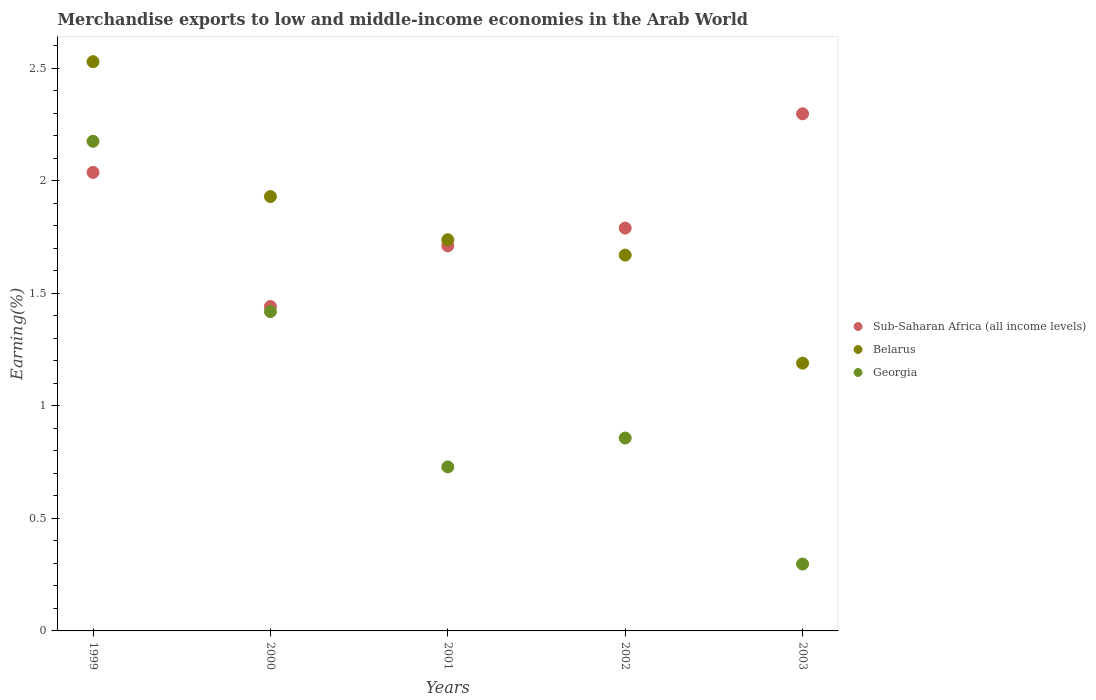How many different coloured dotlines are there?
Your response must be concise. 3. Is the number of dotlines equal to the number of legend labels?
Keep it short and to the point. Yes. What is the percentage of amount earned from merchandise exports in Belarus in 2002?
Offer a very short reply. 1.67. Across all years, what is the maximum percentage of amount earned from merchandise exports in Belarus?
Ensure brevity in your answer.  2.53. Across all years, what is the minimum percentage of amount earned from merchandise exports in Georgia?
Your answer should be very brief. 0.3. What is the total percentage of amount earned from merchandise exports in Sub-Saharan Africa (all income levels) in the graph?
Your answer should be very brief. 9.28. What is the difference between the percentage of amount earned from merchandise exports in Sub-Saharan Africa (all income levels) in 1999 and that in 2001?
Your answer should be compact. 0.33. What is the difference between the percentage of amount earned from merchandise exports in Sub-Saharan Africa (all income levels) in 2002 and the percentage of amount earned from merchandise exports in Georgia in 2001?
Make the answer very short. 1.06. What is the average percentage of amount earned from merchandise exports in Sub-Saharan Africa (all income levels) per year?
Keep it short and to the point. 1.86. In the year 2001, what is the difference between the percentage of amount earned from merchandise exports in Georgia and percentage of amount earned from merchandise exports in Belarus?
Your answer should be compact. -1.01. What is the ratio of the percentage of amount earned from merchandise exports in Sub-Saharan Africa (all income levels) in 2001 to that in 2003?
Your answer should be very brief. 0.74. Is the difference between the percentage of amount earned from merchandise exports in Georgia in 2000 and 2002 greater than the difference between the percentage of amount earned from merchandise exports in Belarus in 2000 and 2002?
Offer a very short reply. Yes. What is the difference between the highest and the second highest percentage of amount earned from merchandise exports in Sub-Saharan Africa (all income levels)?
Your answer should be compact. 0.26. What is the difference between the highest and the lowest percentage of amount earned from merchandise exports in Belarus?
Your answer should be compact. 1.34. In how many years, is the percentage of amount earned from merchandise exports in Sub-Saharan Africa (all income levels) greater than the average percentage of amount earned from merchandise exports in Sub-Saharan Africa (all income levels) taken over all years?
Provide a short and direct response. 2. Is the sum of the percentage of amount earned from merchandise exports in Georgia in 1999 and 2001 greater than the maximum percentage of amount earned from merchandise exports in Belarus across all years?
Make the answer very short. Yes. Does the percentage of amount earned from merchandise exports in Sub-Saharan Africa (all income levels) monotonically increase over the years?
Offer a very short reply. No. How many dotlines are there?
Offer a terse response. 3. How many years are there in the graph?
Ensure brevity in your answer.  5. Are the values on the major ticks of Y-axis written in scientific E-notation?
Ensure brevity in your answer.  No. Does the graph contain any zero values?
Offer a very short reply. No. Does the graph contain grids?
Your response must be concise. No. How many legend labels are there?
Your answer should be compact. 3. How are the legend labels stacked?
Provide a short and direct response. Vertical. What is the title of the graph?
Your response must be concise. Merchandise exports to low and middle-income economies in the Arab World. Does "Kosovo" appear as one of the legend labels in the graph?
Ensure brevity in your answer.  No. What is the label or title of the Y-axis?
Keep it short and to the point. Earning(%). What is the Earning(%) in Sub-Saharan Africa (all income levels) in 1999?
Give a very brief answer. 2.04. What is the Earning(%) in Belarus in 1999?
Offer a terse response. 2.53. What is the Earning(%) of Georgia in 1999?
Provide a short and direct response. 2.18. What is the Earning(%) in Sub-Saharan Africa (all income levels) in 2000?
Provide a succinct answer. 1.44. What is the Earning(%) of Belarus in 2000?
Your response must be concise. 1.93. What is the Earning(%) in Georgia in 2000?
Provide a succinct answer. 1.42. What is the Earning(%) of Sub-Saharan Africa (all income levels) in 2001?
Your response must be concise. 1.71. What is the Earning(%) in Belarus in 2001?
Provide a succinct answer. 1.74. What is the Earning(%) of Georgia in 2001?
Offer a terse response. 0.73. What is the Earning(%) of Sub-Saharan Africa (all income levels) in 2002?
Ensure brevity in your answer.  1.79. What is the Earning(%) of Belarus in 2002?
Offer a very short reply. 1.67. What is the Earning(%) of Georgia in 2002?
Offer a very short reply. 0.86. What is the Earning(%) in Sub-Saharan Africa (all income levels) in 2003?
Your answer should be very brief. 2.3. What is the Earning(%) in Belarus in 2003?
Ensure brevity in your answer.  1.19. What is the Earning(%) of Georgia in 2003?
Give a very brief answer. 0.3. Across all years, what is the maximum Earning(%) of Sub-Saharan Africa (all income levels)?
Your answer should be very brief. 2.3. Across all years, what is the maximum Earning(%) of Belarus?
Offer a terse response. 2.53. Across all years, what is the maximum Earning(%) of Georgia?
Your answer should be compact. 2.18. Across all years, what is the minimum Earning(%) of Sub-Saharan Africa (all income levels)?
Offer a very short reply. 1.44. Across all years, what is the minimum Earning(%) in Belarus?
Provide a short and direct response. 1.19. Across all years, what is the minimum Earning(%) of Georgia?
Offer a very short reply. 0.3. What is the total Earning(%) in Sub-Saharan Africa (all income levels) in the graph?
Offer a terse response. 9.28. What is the total Earning(%) of Belarus in the graph?
Make the answer very short. 9.06. What is the total Earning(%) in Georgia in the graph?
Offer a terse response. 5.48. What is the difference between the Earning(%) of Sub-Saharan Africa (all income levels) in 1999 and that in 2000?
Provide a succinct answer. 0.6. What is the difference between the Earning(%) in Belarus in 1999 and that in 2000?
Offer a very short reply. 0.6. What is the difference between the Earning(%) in Georgia in 1999 and that in 2000?
Keep it short and to the point. 0.76. What is the difference between the Earning(%) in Sub-Saharan Africa (all income levels) in 1999 and that in 2001?
Keep it short and to the point. 0.33. What is the difference between the Earning(%) of Belarus in 1999 and that in 2001?
Make the answer very short. 0.79. What is the difference between the Earning(%) of Georgia in 1999 and that in 2001?
Your answer should be compact. 1.45. What is the difference between the Earning(%) of Sub-Saharan Africa (all income levels) in 1999 and that in 2002?
Provide a succinct answer. 0.25. What is the difference between the Earning(%) in Belarus in 1999 and that in 2002?
Make the answer very short. 0.86. What is the difference between the Earning(%) of Georgia in 1999 and that in 2002?
Provide a succinct answer. 1.32. What is the difference between the Earning(%) in Sub-Saharan Africa (all income levels) in 1999 and that in 2003?
Give a very brief answer. -0.26. What is the difference between the Earning(%) in Belarus in 1999 and that in 2003?
Provide a short and direct response. 1.34. What is the difference between the Earning(%) in Georgia in 1999 and that in 2003?
Ensure brevity in your answer.  1.88. What is the difference between the Earning(%) of Sub-Saharan Africa (all income levels) in 2000 and that in 2001?
Provide a short and direct response. -0.27. What is the difference between the Earning(%) in Belarus in 2000 and that in 2001?
Keep it short and to the point. 0.19. What is the difference between the Earning(%) of Georgia in 2000 and that in 2001?
Provide a succinct answer. 0.69. What is the difference between the Earning(%) in Sub-Saharan Africa (all income levels) in 2000 and that in 2002?
Your response must be concise. -0.35. What is the difference between the Earning(%) of Belarus in 2000 and that in 2002?
Keep it short and to the point. 0.26. What is the difference between the Earning(%) in Georgia in 2000 and that in 2002?
Your answer should be very brief. 0.56. What is the difference between the Earning(%) of Sub-Saharan Africa (all income levels) in 2000 and that in 2003?
Keep it short and to the point. -0.86. What is the difference between the Earning(%) of Belarus in 2000 and that in 2003?
Provide a succinct answer. 0.74. What is the difference between the Earning(%) of Georgia in 2000 and that in 2003?
Your answer should be very brief. 1.12. What is the difference between the Earning(%) in Sub-Saharan Africa (all income levels) in 2001 and that in 2002?
Your response must be concise. -0.08. What is the difference between the Earning(%) in Belarus in 2001 and that in 2002?
Provide a succinct answer. 0.07. What is the difference between the Earning(%) of Georgia in 2001 and that in 2002?
Keep it short and to the point. -0.13. What is the difference between the Earning(%) of Sub-Saharan Africa (all income levels) in 2001 and that in 2003?
Your response must be concise. -0.59. What is the difference between the Earning(%) of Belarus in 2001 and that in 2003?
Your response must be concise. 0.55. What is the difference between the Earning(%) of Georgia in 2001 and that in 2003?
Your response must be concise. 0.43. What is the difference between the Earning(%) of Sub-Saharan Africa (all income levels) in 2002 and that in 2003?
Your answer should be compact. -0.51. What is the difference between the Earning(%) of Belarus in 2002 and that in 2003?
Make the answer very short. 0.48. What is the difference between the Earning(%) in Georgia in 2002 and that in 2003?
Give a very brief answer. 0.56. What is the difference between the Earning(%) of Sub-Saharan Africa (all income levels) in 1999 and the Earning(%) of Belarus in 2000?
Give a very brief answer. 0.11. What is the difference between the Earning(%) in Sub-Saharan Africa (all income levels) in 1999 and the Earning(%) in Georgia in 2000?
Provide a short and direct response. 0.62. What is the difference between the Earning(%) in Belarus in 1999 and the Earning(%) in Georgia in 2000?
Your answer should be very brief. 1.11. What is the difference between the Earning(%) in Sub-Saharan Africa (all income levels) in 1999 and the Earning(%) in Belarus in 2001?
Keep it short and to the point. 0.3. What is the difference between the Earning(%) of Sub-Saharan Africa (all income levels) in 1999 and the Earning(%) of Georgia in 2001?
Ensure brevity in your answer.  1.31. What is the difference between the Earning(%) in Belarus in 1999 and the Earning(%) in Georgia in 2001?
Your answer should be compact. 1.8. What is the difference between the Earning(%) of Sub-Saharan Africa (all income levels) in 1999 and the Earning(%) of Belarus in 2002?
Give a very brief answer. 0.37. What is the difference between the Earning(%) in Sub-Saharan Africa (all income levels) in 1999 and the Earning(%) in Georgia in 2002?
Your answer should be very brief. 1.18. What is the difference between the Earning(%) in Belarus in 1999 and the Earning(%) in Georgia in 2002?
Provide a short and direct response. 1.67. What is the difference between the Earning(%) of Sub-Saharan Africa (all income levels) in 1999 and the Earning(%) of Belarus in 2003?
Provide a short and direct response. 0.85. What is the difference between the Earning(%) of Sub-Saharan Africa (all income levels) in 1999 and the Earning(%) of Georgia in 2003?
Provide a short and direct response. 1.74. What is the difference between the Earning(%) of Belarus in 1999 and the Earning(%) of Georgia in 2003?
Your response must be concise. 2.23. What is the difference between the Earning(%) in Sub-Saharan Africa (all income levels) in 2000 and the Earning(%) in Belarus in 2001?
Offer a terse response. -0.3. What is the difference between the Earning(%) of Sub-Saharan Africa (all income levels) in 2000 and the Earning(%) of Georgia in 2001?
Ensure brevity in your answer.  0.71. What is the difference between the Earning(%) in Belarus in 2000 and the Earning(%) in Georgia in 2001?
Provide a short and direct response. 1.2. What is the difference between the Earning(%) in Sub-Saharan Africa (all income levels) in 2000 and the Earning(%) in Belarus in 2002?
Offer a terse response. -0.23. What is the difference between the Earning(%) in Sub-Saharan Africa (all income levels) in 2000 and the Earning(%) in Georgia in 2002?
Offer a very short reply. 0.58. What is the difference between the Earning(%) of Belarus in 2000 and the Earning(%) of Georgia in 2002?
Give a very brief answer. 1.07. What is the difference between the Earning(%) in Sub-Saharan Africa (all income levels) in 2000 and the Earning(%) in Belarus in 2003?
Your response must be concise. 0.25. What is the difference between the Earning(%) in Sub-Saharan Africa (all income levels) in 2000 and the Earning(%) in Georgia in 2003?
Ensure brevity in your answer.  1.14. What is the difference between the Earning(%) in Belarus in 2000 and the Earning(%) in Georgia in 2003?
Offer a terse response. 1.63. What is the difference between the Earning(%) in Sub-Saharan Africa (all income levels) in 2001 and the Earning(%) in Belarus in 2002?
Keep it short and to the point. 0.04. What is the difference between the Earning(%) of Sub-Saharan Africa (all income levels) in 2001 and the Earning(%) of Georgia in 2002?
Give a very brief answer. 0.85. What is the difference between the Earning(%) of Belarus in 2001 and the Earning(%) of Georgia in 2002?
Offer a very short reply. 0.88. What is the difference between the Earning(%) in Sub-Saharan Africa (all income levels) in 2001 and the Earning(%) in Belarus in 2003?
Your answer should be compact. 0.52. What is the difference between the Earning(%) in Sub-Saharan Africa (all income levels) in 2001 and the Earning(%) in Georgia in 2003?
Give a very brief answer. 1.41. What is the difference between the Earning(%) in Belarus in 2001 and the Earning(%) in Georgia in 2003?
Make the answer very short. 1.44. What is the difference between the Earning(%) in Sub-Saharan Africa (all income levels) in 2002 and the Earning(%) in Belarus in 2003?
Provide a short and direct response. 0.6. What is the difference between the Earning(%) of Sub-Saharan Africa (all income levels) in 2002 and the Earning(%) of Georgia in 2003?
Ensure brevity in your answer.  1.49. What is the difference between the Earning(%) in Belarus in 2002 and the Earning(%) in Georgia in 2003?
Make the answer very short. 1.37. What is the average Earning(%) of Sub-Saharan Africa (all income levels) per year?
Give a very brief answer. 1.86. What is the average Earning(%) of Belarus per year?
Keep it short and to the point. 1.81. What is the average Earning(%) in Georgia per year?
Your response must be concise. 1.1. In the year 1999, what is the difference between the Earning(%) in Sub-Saharan Africa (all income levels) and Earning(%) in Belarus?
Your answer should be compact. -0.49. In the year 1999, what is the difference between the Earning(%) in Sub-Saharan Africa (all income levels) and Earning(%) in Georgia?
Provide a short and direct response. -0.14. In the year 1999, what is the difference between the Earning(%) of Belarus and Earning(%) of Georgia?
Your answer should be compact. 0.35. In the year 2000, what is the difference between the Earning(%) in Sub-Saharan Africa (all income levels) and Earning(%) in Belarus?
Offer a terse response. -0.49. In the year 2000, what is the difference between the Earning(%) in Sub-Saharan Africa (all income levels) and Earning(%) in Georgia?
Offer a terse response. 0.02. In the year 2000, what is the difference between the Earning(%) of Belarus and Earning(%) of Georgia?
Your answer should be very brief. 0.51. In the year 2001, what is the difference between the Earning(%) in Sub-Saharan Africa (all income levels) and Earning(%) in Belarus?
Your answer should be compact. -0.03. In the year 2001, what is the difference between the Earning(%) in Sub-Saharan Africa (all income levels) and Earning(%) in Georgia?
Keep it short and to the point. 0.98. In the year 2001, what is the difference between the Earning(%) in Belarus and Earning(%) in Georgia?
Give a very brief answer. 1.01. In the year 2002, what is the difference between the Earning(%) in Sub-Saharan Africa (all income levels) and Earning(%) in Belarus?
Keep it short and to the point. 0.12. In the year 2002, what is the difference between the Earning(%) of Sub-Saharan Africa (all income levels) and Earning(%) of Georgia?
Your response must be concise. 0.93. In the year 2002, what is the difference between the Earning(%) in Belarus and Earning(%) in Georgia?
Give a very brief answer. 0.81. In the year 2003, what is the difference between the Earning(%) in Sub-Saharan Africa (all income levels) and Earning(%) in Belarus?
Your answer should be compact. 1.11. In the year 2003, what is the difference between the Earning(%) in Sub-Saharan Africa (all income levels) and Earning(%) in Georgia?
Give a very brief answer. 2. In the year 2003, what is the difference between the Earning(%) in Belarus and Earning(%) in Georgia?
Provide a succinct answer. 0.89. What is the ratio of the Earning(%) in Sub-Saharan Africa (all income levels) in 1999 to that in 2000?
Offer a very short reply. 1.41. What is the ratio of the Earning(%) in Belarus in 1999 to that in 2000?
Your answer should be compact. 1.31. What is the ratio of the Earning(%) in Georgia in 1999 to that in 2000?
Your answer should be very brief. 1.53. What is the ratio of the Earning(%) in Sub-Saharan Africa (all income levels) in 1999 to that in 2001?
Offer a terse response. 1.19. What is the ratio of the Earning(%) in Belarus in 1999 to that in 2001?
Your answer should be compact. 1.46. What is the ratio of the Earning(%) of Georgia in 1999 to that in 2001?
Your answer should be very brief. 2.99. What is the ratio of the Earning(%) of Sub-Saharan Africa (all income levels) in 1999 to that in 2002?
Your answer should be very brief. 1.14. What is the ratio of the Earning(%) in Belarus in 1999 to that in 2002?
Offer a terse response. 1.51. What is the ratio of the Earning(%) of Georgia in 1999 to that in 2002?
Your answer should be very brief. 2.54. What is the ratio of the Earning(%) in Sub-Saharan Africa (all income levels) in 1999 to that in 2003?
Your response must be concise. 0.89. What is the ratio of the Earning(%) of Belarus in 1999 to that in 2003?
Offer a terse response. 2.13. What is the ratio of the Earning(%) of Georgia in 1999 to that in 2003?
Provide a short and direct response. 7.32. What is the ratio of the Earning(%) of Sub-Saharan Africa (all income levels) in 2000 to that in 2001?
Keep it short and to the point. 0.84. What is the ratio of the Earning(%) of Belarus in 2000 to that in 2001?
Ensure brevity in your answer.  1.11. What is the ratio of the Earning(%) of Georgia in 2000 to that in 2001?
Provide a succinct answer. 1.95. What is the ratio of the Earning(%) of Sub-Saharan Africa (all income levels) in 2000 to that in 2002?
Provide a short and direct response. 0.81. What is the ratio of the Earning(%) in Belarus in 2000 to that in 2002?
Make the answer very short. 1.16. What is the ratio of the Earning(%) of Georgia in 2000 to that in 2002?
Your answer should be compact. 1.66. What is the ratio of the Earning(%) of Sub-Saharan Africa (all income levels) in 2000 to that in 2003?
Ensure brevity in your answer.  0.63. What is the ratio of the Earning(%) in Belarus in 2000 to that in 2003?
Offer a terse response. 1.62. What is the ratio of the Earning(%) in Georgia in 2000 to that in 2003?
Provide a succinct answer. 4.77. What is the ratio of the Earning(%) in Sub-Saharan Africa (all income levels) in 2001 to that in 2002?
Give a very brief answer. 0.96. What is the ratio of the Earning(%) in Belarus in 2001 to that in 2002?
Offer a terse response. 1.04. What is the ratio of the Earning(%) in Georgia in 2001 to that in 2002?
Your answer should be compact. 0.85. What is the ratio of the Earning(%) in Sub-Saharan Africa (all income levels) in 2001 to that in 2003?
Your answer should be compact. 0.74. What is the ratio of the Earning(%) of Belarus in 2001 to that in 2003?
Your response must be concise. 1.46. What is the ratio of the Earning(%) of Georgia in 2001 to that in 2003?
Ensure brevity in your answer.  2.45. What is the ratio of the Earning(%) in Sub-Saharan Africa (all income levels) in 2002 to that in 2003?
Ensure brevity in your answer.  0.78. What is the ratio of the Earning(%) of Belarus in 2002 to that in 2003?
Your answer should be compact. 1.4. What is the ratio of the Earning(%) in Georgia in 2002 to that in 2003?
Offer a very short reply. 2.88. What is the difference between the highest and the second highest Earning(%) in Sub-Saharan Africa (all income levels)?
Make the answer very short. 0.26. What is the difference between the highest and the second highest Earning(%) of Belarus?
Your answer should be compact. 0.6. What is the difference between the highest and the second highest Earning(%) in Georgia?
Make the answer very short. 0.76. What is the difference between the highest and the lowest Earning(%) of Sub-Saharan Africa (all income levels)?
Keep it short and to the point. 0.86. What is the difference between the highest and the lowest Earning(%) of Belarus?
Your response must be concise. 1.34. What is the difference between the highest and the lowest Earning(%) in Georgia?
Give a very brief answer. 1.88. 